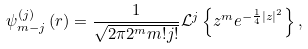<formula> <loc_0><loc_0><loc_500><loc_500>\psi ^ { ( j ) } _ { m - j } \left ( { r } \right ) = \frac { 1 } { \sqrt { 2 \pi 2 ^ { m } m ! j ! } } \mathcal { L } ^ { j } \left \{ z ^ { m } e ^ { - \frac { 1 } { 4 } \left | z \right | ^ { 2 } } \right \} ,</formula> 